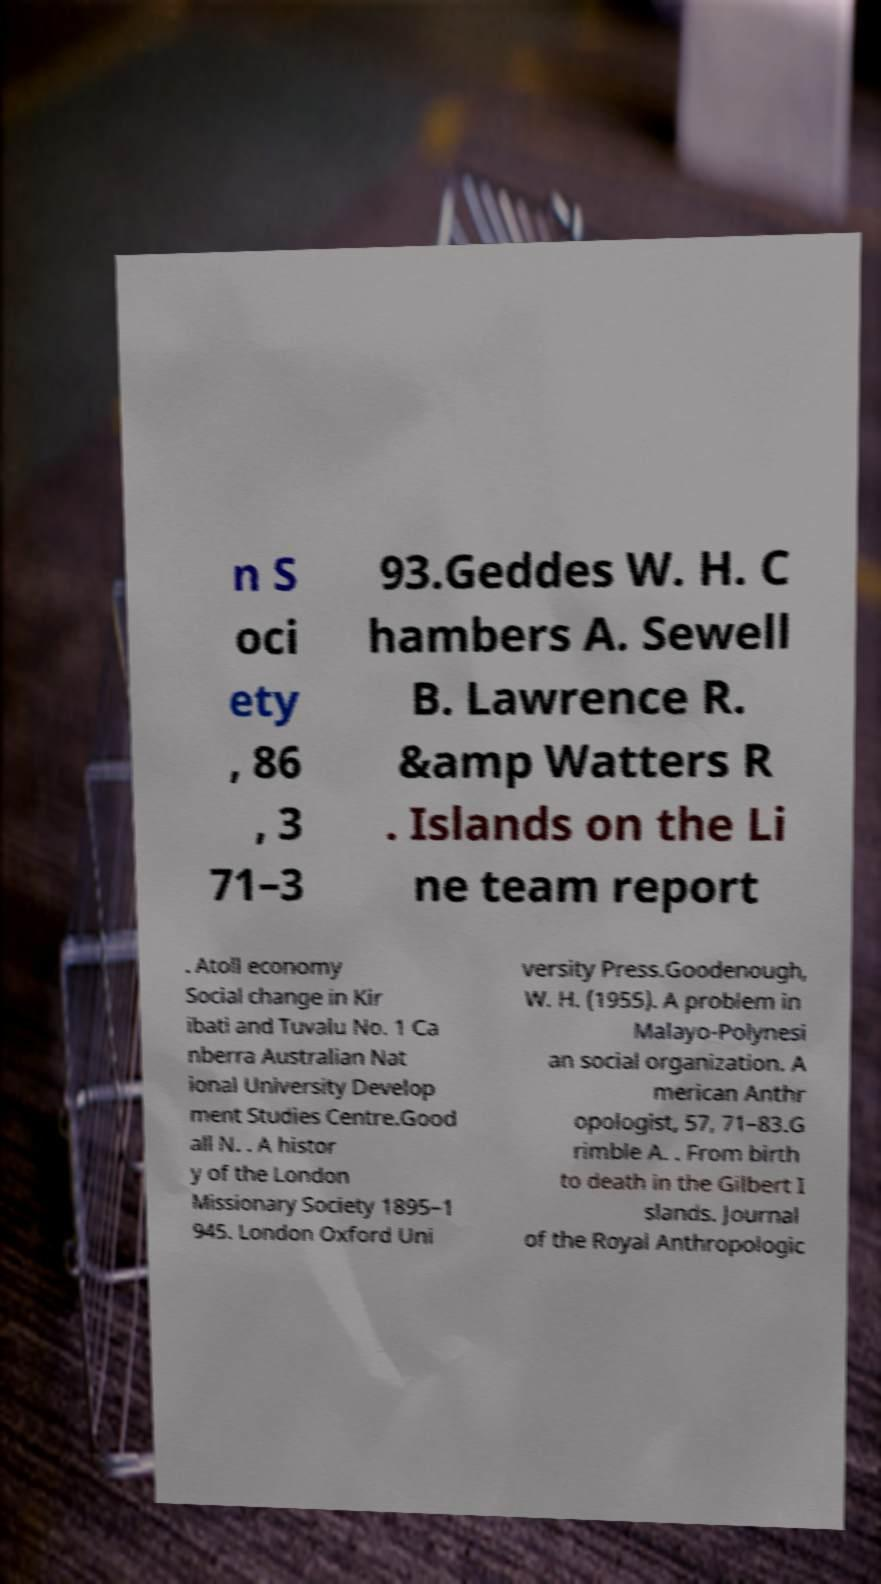Can you accurately transcribe the text from the provided image for me? n S oci ety , 86 , 3 71–3 93.Geddes W. H. C hambers A. Sewell B. Lawrence R. &amp Watters R . Islands on the Li ne team report . Atoll economy Social change in Kir ibati and Tuvalu No. 1 Ca nberra Australian Nat ional University Develop ment Studies Centre.Good all N. . A histor y of the London Missionary Society 1895–1 945. London Oxford Uni versity Press.Goodenough, W. H. (1955). A problem in Malayo-Polynesi an social organization. A merican Anthr opologist, 57, 71–83.G rimble A. . From birth to death in the Gilbert I slands. Journal of the Royal Anthropologic 